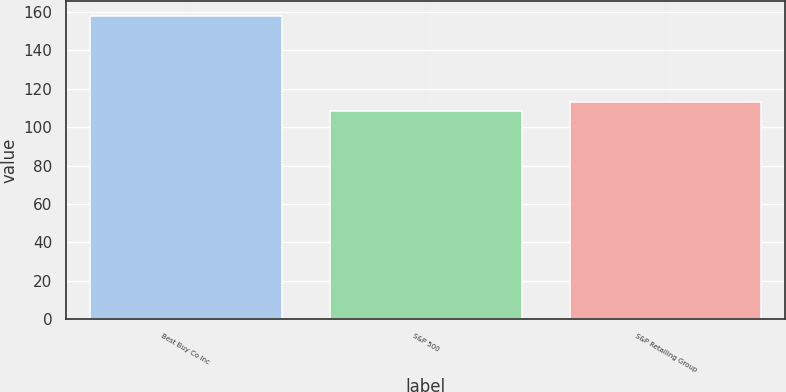<chart> <loc_0><loc_0><loc_500><loc_500><bar_chart><fcel>Best Buy Co Inc<fcel>S&P 500<fcel>S&P Retailing Group<nl><fcel>158<fcel>108.4<fcel>113.36<nl></chart> 